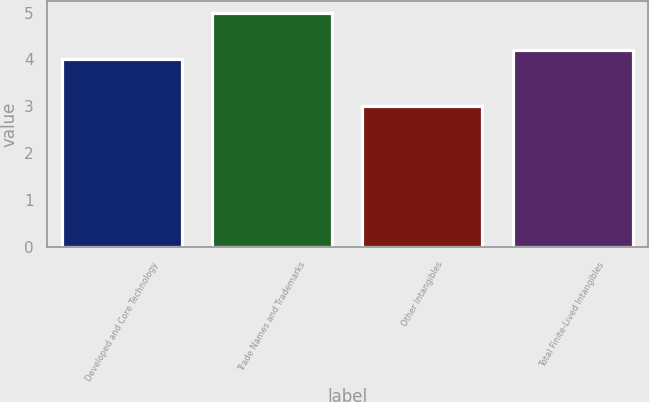<chart> <loc_0><loc_0><loc_500><loc_500><bar_chart><fcel>Developed and Core Technology<fcel>Trade Names and Trademarks<fcel>Other Intangibles<fcel>Total Finite-Lived Intangibles<nl><fcel>4<fcel>5<fcel>3<fcel>4.2<nl></chart> 